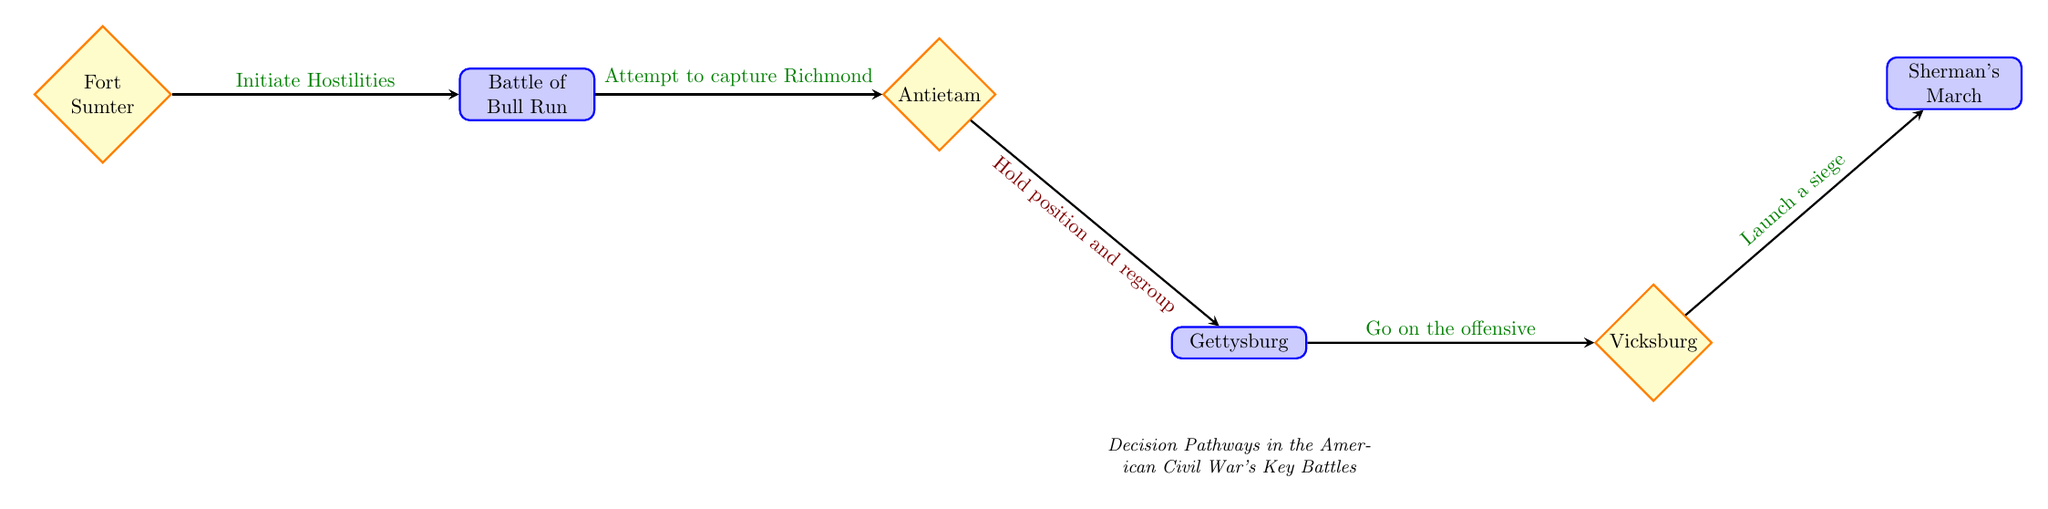What is the first decision point in the diagram? The first decision point in the diagram is labeled "Fort Sumter," indicating the initial choice made that leads into the series of events depicted.
Answer: Fort Sumter How many nodes are present in this flow chart? By counting all the distinct decision points and outcomes in the diagram, there are a total of six nodes represented.
Answer: 6 What happens if the Union decides not to pursue Lee at Antietam? If the Union decides not to pursue Lee's forces at Antietam, as indicated by the "no" pathway, they would hold their position and regroup instead of engaging further.
Answer: Hold position and regroup Which outcome directly follows the decision to launch a siege at Vicksburg? The outcome that directly follows the decision to "Launch a siege" at Vicksburg is the implementation of "Sherman's March to the Sea," signifying the progression of the strategy.
Answer: Sherman’s March to the Sea What decision leads to the Battle of Bull Run? The decision leading to the Battle of Bull Run is the Confederate choice to "Initiate Hostilities" after firing on Fort Sumter, which sets the stage for further military engagements.
Answer: Initiate Hostilities What would have been the result had Lee chosen to retreat and regroup at Gettysburg? If Lee had chosen to "Retreat and regroup" at Gettysburg, it implies he would avoid confrontation and give the Union a strategic advantage without engaging in Pickett's Charge.
Answer: Retreat and regroup 